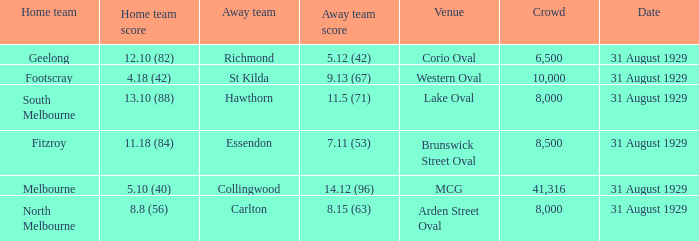What is the biggest gathering when the visiting team is hawthorn? 8000.0. 